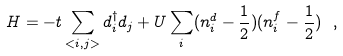<formula> <loc_0><loc_0><loc_500><loc_500>H = - t \sum _ { < i , j > } d ^ { \dagger } _ { i } d _ { j } + U \sum _ { i } ( n ^ { d } _ { i } - \frac { 1 } { 2 } ) ( n ^ { f } _ { i } - \frac { 1 } { 2 } ) \ ,</formula> 